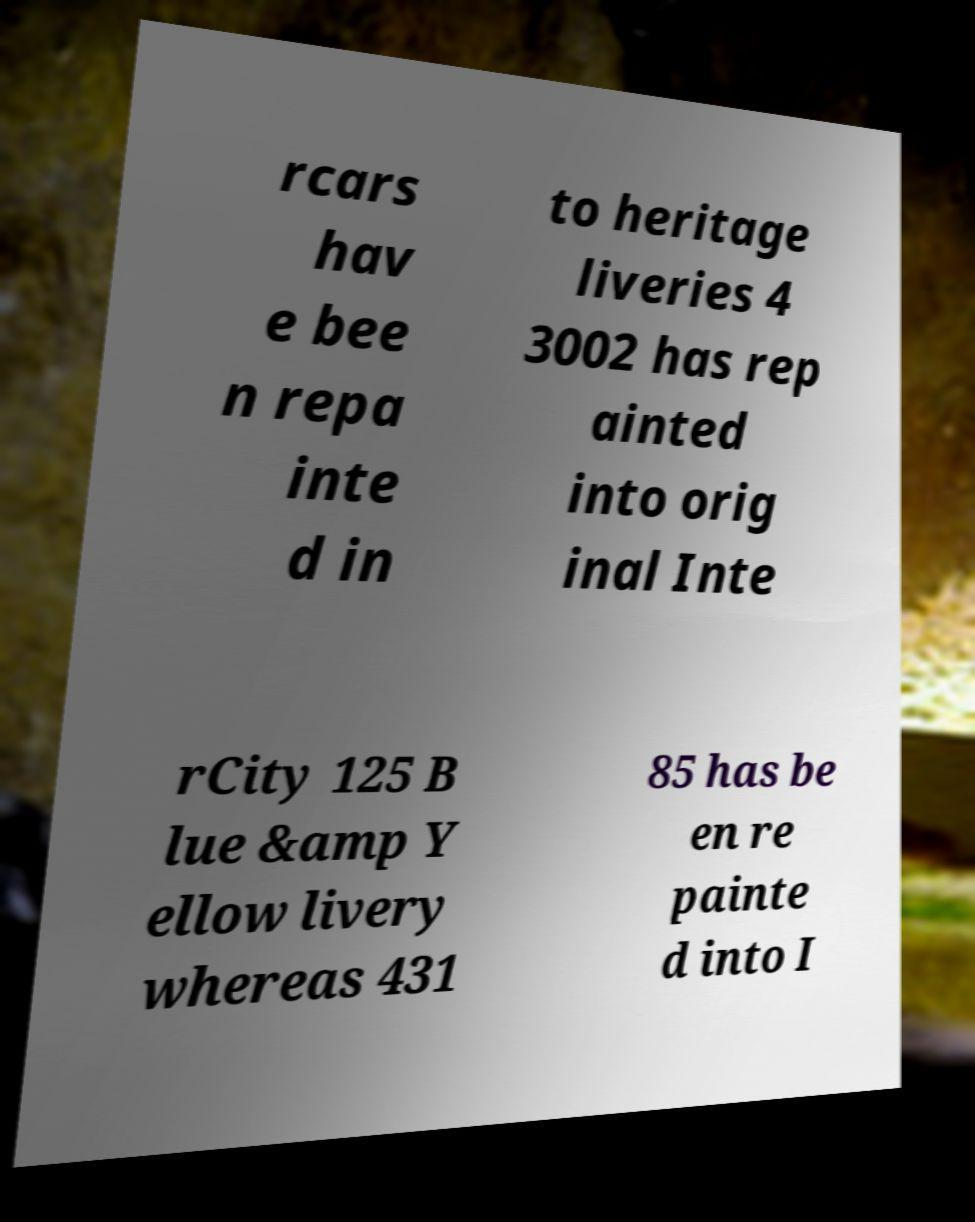Please read and relay the text visible in this image. What does it say? rcars hav e bee n repa inte d in to heritage liveries 4 3002 has rep ainted into orig inal Inte rCity 125 B lue &amp Y ellow livery whereas 431 85 has be en re painte d into I 